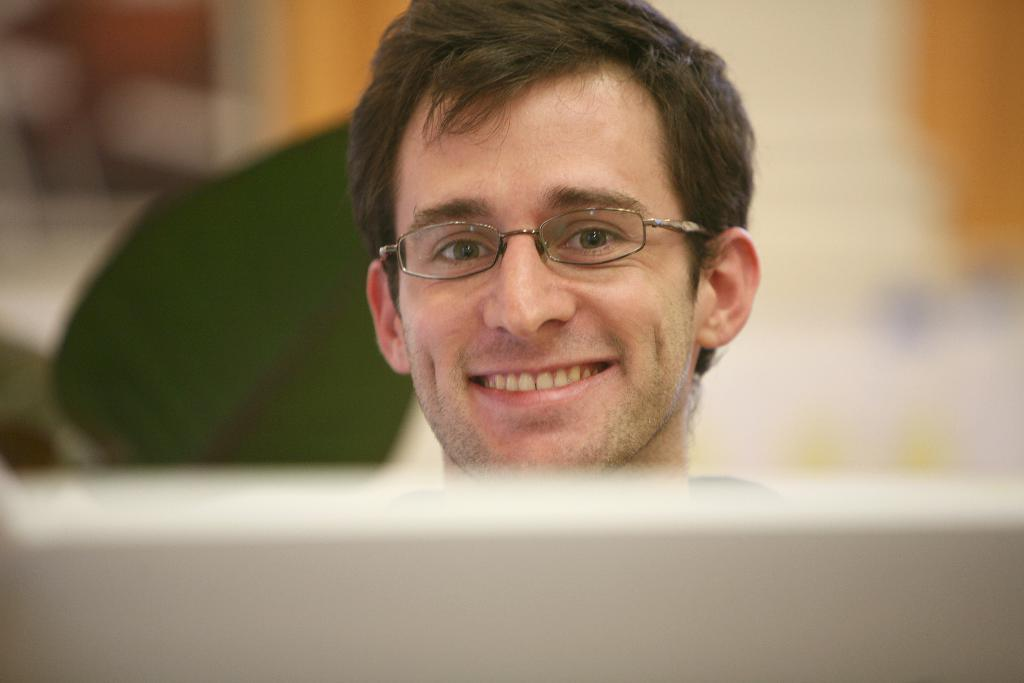What is present in the image? There is a man in the image. How is the man's expression in the image? The man is smiling in the image. What type of glove is the man wearing in the image? There is no glove present in the image; the man is not wearing any gloves. 